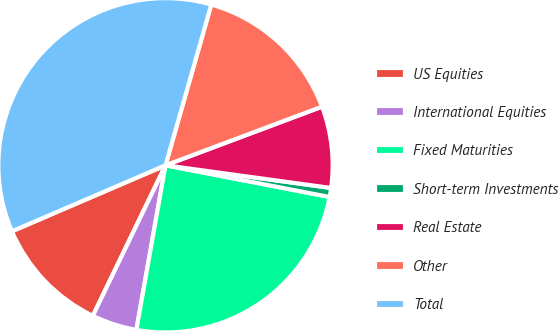Convert chart. <chart><loc_0><loc_0><loc_500><loc_500><pie_chart><fcel>US Equities<fcel>International Equities<fcel>Fixed Maturities<fcel>Short-term Investments<fcel>Real Estate<fcel>Other<fcel>Total<nl><fcel>11.38%<fcel>4.37%<fcel>24.75%<fcel>0.87%<fcel>7.87%<fcel>14.88%<fcel>35.87%<nl></chart> 